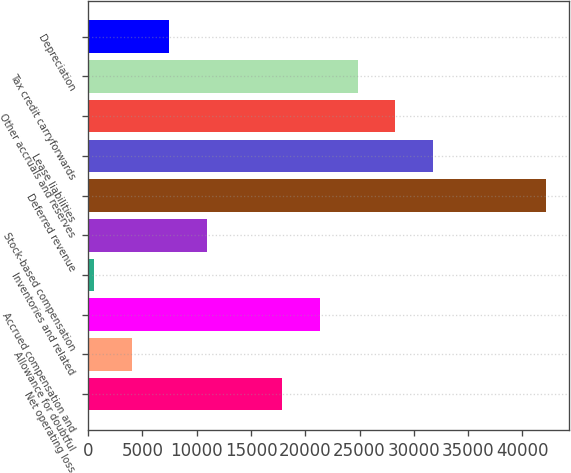Convert chart. <chart><loc_0><loc_0><loc_500><loc_500><bar_chart><fcel>Net operating loss<fcel>Allowance for doubtful<fcel>Accrued compensation and<fcel>Inventories and related<fcel>Stock-based compensation<fcel>Deferred revenue<fcel>Lease liabilities<fcel>Other accruals and reserves<fcel>Tax credit carryforwards<fcel>Depreciation<nl><fcel>17886.5<fcel>3998.1<fcel>21358.6<fcel>526<fcel>10942.3<fcel>42191.2<fcel>31774.9<fcel>28302.8<fcel>24830.7<fcel>7470.2<nl></chart> 